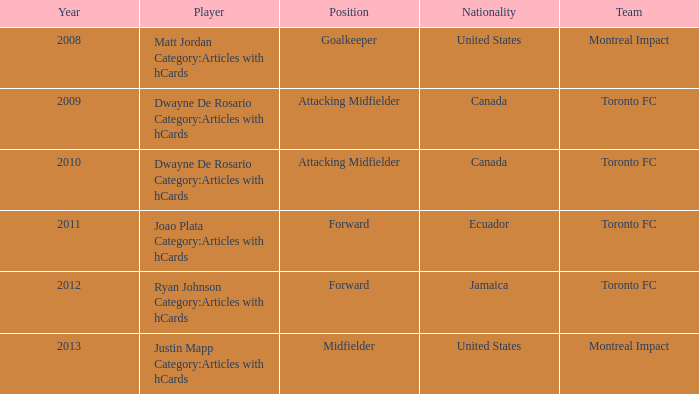After 2009, what is the nationality of a player called dwayne de rosario in the category of articles with hcards? Canada. 